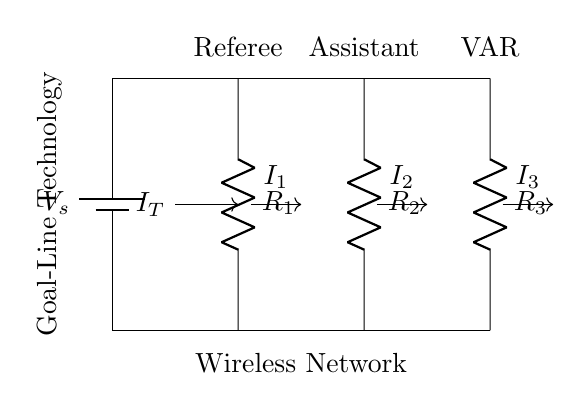What components are present in the circuit? The circuit diagram shows three resistors labeled R1, R2, and R3, and a battery labeled V_s.
Answer: R1, R2, R3, V_s What does the abbreviation VAR in the circuit stand for? VAR stands for Video Assistant Referee, indicated by the label over the third resistor in the diagram.
Answer: Video Assistant Referee What is the total current entering the circuit? The total current entering the circuit is represented by I_T, which flows from the battery into the parallel branches of resistors.
Answer: I_T Which component corresponds to the referee's headset in this circuit? The resistor R1 corresponds to the referee's headset, as indicated by its label and position in the circuit.
Answer: R1 How can the current through each resistor be determined? The current through each resistor can be determined using the current divider rule, which states that the current divides inversely proportional to the resistance values in parallel.
Answer: Current divider rule What role does the wireless network play in this circuit? The wireless network is indicated as the path through which the total current flows before splitting into individual currents for each component.
Answer: Connectivity What would happen to the current through R2 if R3 is removed from the circuit? If R3 is removed, the total resistance decreases, leading to an increase in the total current I_T, which would also increase the current through R2 according to the current divider rule.
Answer: Increase 